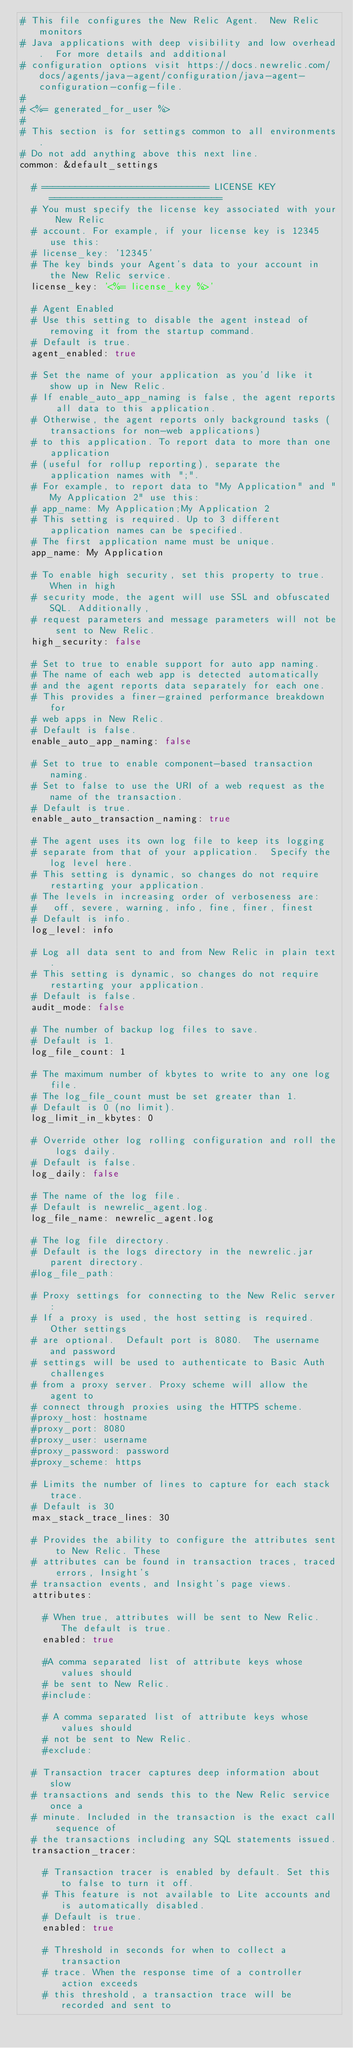<code> <loc_0><loc_0><loc_500><loc_500><_YAML_># This file configures the New Relic Agent.  New Relic monitors
# Java applications with deep visibility and low overhead.  For more details and additional
# configuration options visit https://docs.newrelic.com/docs/agents/java-agent/configuration/java-agent-configuration-config-file.
#
# <%= generated_for_user %>
#
# This section is for settings common to all environments.
# Do not add anything above this next line.
common: &default_settings

  # ============================== LICENSE KEY ===============================
  # You must specify the license key associated with your New Relic
  # account. For example, if your license key is 12345 use this:
  # license_key: '12345'
  # The key binds your Agent's data to your account in the New Relic service.
  license_key: '<%= license_key %>'

  # Agent Enabled
  # Use this setting to disable the agent instead of removing it from the startup command.
  # Default is true.
  agent_enabled: true

  # Set the name of your application as you'd like it show up in New Relic.
  # If enable_auto_app_naming is false, the agent reports all data to this application.
  # Otherwise, the agent reports only background tasks (transactions for non-web applications)
  # to this application. To report data to more than one application 
  # (useful for rollup reporting), separate the application names with ";".
  # For example, to report data to "My Application" and "My Application 2" use this:
  # app_name: My Application;My Application 2
  # This setting is required. Up to 3 different application names can be specified.
  # The first application name must be unique.
  app_name: My Application

  # To enable high security, set this property to true. When in high
  # security mode, the agent will use SSL and obfuscated SQL. Additionally,
  # request parameters and message parameters will not be sent to New Relic.
  high_security: false

  # Set to true to enable support for auto app naming.
  # The name of each web app is detected automatically
  # and the agent reports data separately for each one.
  # This provides a finer-grained performance breakdown for
  # web apps in New Relic.
  # Default is false.
  enable_auto_app_naming: false

  # Set to true to enable component-based transaction naming.
  # Set to false to use the URI of a web request as the name of the transaction.
  # Default is true.
  enable_auto_transaction_naming: true

  # The agent uses its own log file to keep its logging
  # separate from that of your application.  Specify the log level here.
  # This setting is dynamic, so changes do not require restarting your application.
  # The levels in increasing order of verboseness are:
  #   off, severe, warning, info, fine, finer, finest
  # Default is info.
  log_level: info

  # Log all data sent to and from New Relic in plain text.
  # This setting is dynamic, so changes do not require restarting your application.
  # Default is false.
  audit_mode: false

  # The number of backup log files to save.
  # Default is 1.
  log_file_count: 1

  # The maximum number of kbytes to write to any one log file.
  # The log_file_count must be set greater than 1.
  # Default is 0 (no limit).
  log_limit_in_kbytes: 0

  # Override other log rolling configuration and roll the logs daily.
  # Default is false.
  log_daily: false

  # The name of the log file.
  # Default is newrelic_agent.log.
  log_file_name: newrelic_agent.log

  # The log file directory.
  # Default is the logs directory in the newrelic.jar parent directory.
  #log_file_path:

  # Proxy settings for connecting to the New Relic server:
  # If a proxy is used, the host setting is required.  Other settings
  # are optional.  Default port is 8080.  The username and password
  # settings will be used to authenticate to Basic Auth challenges
  # from a proxy server. Proxy scheme will allow the agent to
  # connect through proxies using the HTTPS scheme.
  #proxy_host: hostname
  #proxy_port: 8080
  #proxy_user: username
  #proxy_password: password
  #proxy_scheme: https

  # Limits the number of lines to capture for each stack trace. 
  # Default is 30
  max_stack_trace_lines: 30

  # Provides the ability to configure the attributes sent to New Relic. These
  # attributes can be found in transaction traces, traced errors, Insight's 
  # transaction events, and Insight's page views.
  attributes:
  
    # When true, attributes will be sent to New Relic. The default is true.
    enabled: true
    
    #A comma separated list of attribute keys whose values should 
    # be sent to New Relic.
    #include:
    
    # A comma separated list of attribute keys whose values should 
    # not be sent to New Relic.
    #exclude:

  # Transaction tracer captures deep information about slow
  # transactions and sends this to the New Relic service once a
  # minute. Included in the transaction is the exact call sequence of
  # the transactions including any SQL statements issued.
  transaction_tracer:

    # Transaction tracer is enabled by default. Set this to false to turn it off.
    # This feature is not available to Lite accounts and is automatically disabled.
    # Default is true.
    enabled: true

    # Threshold in seconds for when to collect a transaction
    # trace. When the response time of a controller action exceeds
    # this threshold, a transaction trace will be recorded and sent to</code> 